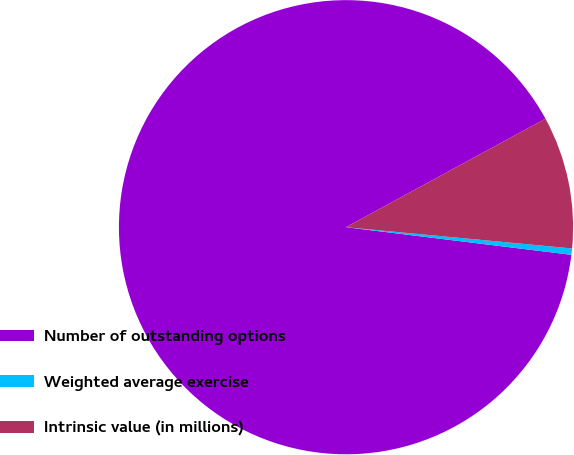<chart> <loc_0><loc_0><loc_500><loc_500><pie_chart><fcel>Number of outstanding options<fcel>Weighted average exercise<fcel>Intrinsic value (in millions)<nl><fcel>90.13%<fcel>0.45%<fcel>9.42%<nl></chart> 